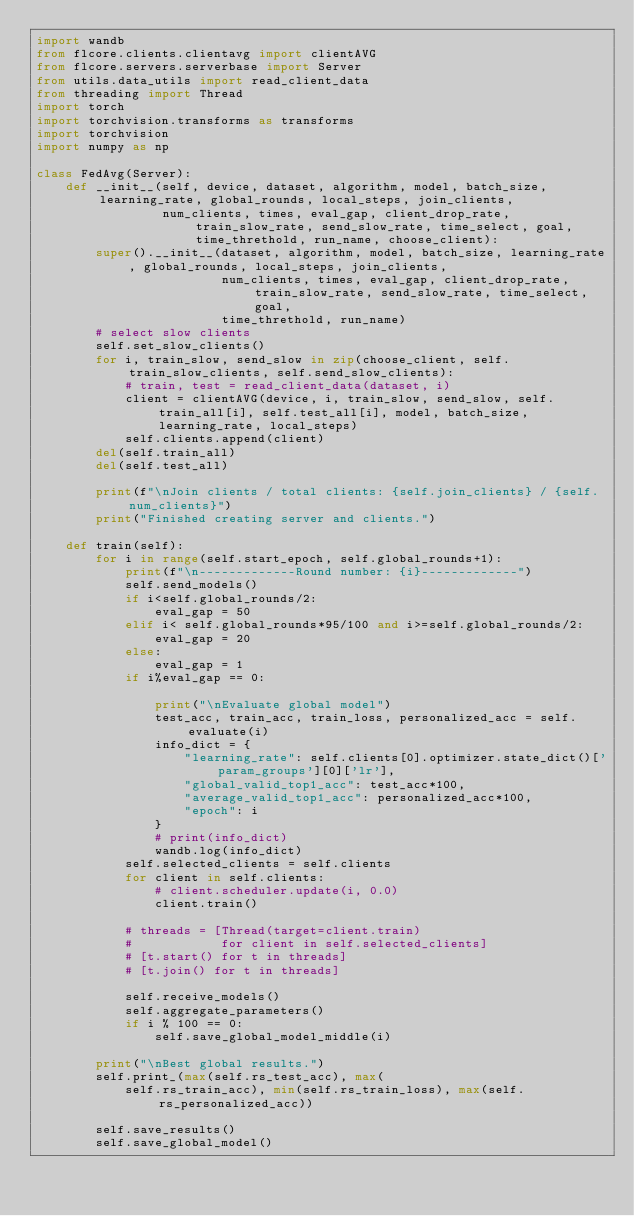<code> <loc_0><loc_0><loc_500><loc_500><_Python_>import wandb
from flcore.clients.clientavg import clientAVG
from flcore.servers.serverbase import Server
from utils.data_utils import read_client_data
from threading import Thread
import torch
import torchvision.transforms as transforms
import torchvision
import numpy as np

class FedAvg(Server):
    def __init__(self, device, dataset, algorithm, model, batch_size, learning_rate, global_rounds, local_steps, join_clients,
                 num_clients, times, eval_gap, client_drop_rate, train_slow_rate, send_slow_rate, time_select, goal, time_threthold, run_name, choose_client):
        super().__init__(dataset, algorithm, model, batch_size, learning_rate, global_rounds, local_steps, join_clients,
                         num_clients, times, eval_gap, client_drop_rate, train_slow_rate, send_slow_rate, time_select, goal, 
                         time_threthold, run_name)
        # select slow clients
        self.set_slow_clients()
        for i, train_slow, send_slow in zip(choose_client, self.train_slow_clients, self.send_slow_clients):
            # train, test = read_client_data(dataset, i)
            client = clientAVG(device, i, train_slow, send_slow, self.train_all[i], self.test_all[i], model, batch_size, learning_rate, local_steps)
            self.clients.append(client)
        del(self.train_all)
        del(self.test_all)

        print(f"\nJoin clients / total clients: {self.join_clients} / {self.num_clients}")
        print("Finished creating server and clients.")

    def train(self):
        for i in range(self.start_epoch, self.global_rounds+1):
            print(f"\n-------------Round number: {i}-------------")
            self.send_models()
            if i<self.global_rounds/2:
                eval_gap = 50
            elif i< self.global_rounds*95/100 and i>=self.global_rounds/2:
                eval_gap = 20
            else:
                eval_gap = 1
            if i%eval_gap == 0:

                print("\nEvaluate global model")
                test_acc, train_acc, train_loss, personalized_acc = self.evaluate(i)
                info_dict = {
                    "learning_rate": self.clients[0].optimizer.state_dict()['param_groups'][0]['lr'],
                    "global_valid_top1_acc": test_acc*100,
                    "average_valid_top1_acc": personalized_acc*100,
                    "epoch": i
                }
                # print(info_dict)
                wandb.log(info_dict)
            self.selected_clients = self.clients
            for client in self.clients:
                # client.scheduler.update(i, 0.0)
                client.train()

            # threads = [Thread(target=client.train)
            #            for client in self.selected_clients]
            # [t.start() for t in threads]
            # [t.join() for t in threads]

            self.receive_models()
            self.aggregate_parameters()
            if i % 100 == 0:
                self.save_global_model_middle(i)

        print("\nBest global results.")
        self.print_(max(self.rs_test_acc), max(
            self.rs_train_acc), min(self.rs_train_loss), max(self.rs_personalized_acc))

        self.save_results()
        self.save_global_model()
</code> 